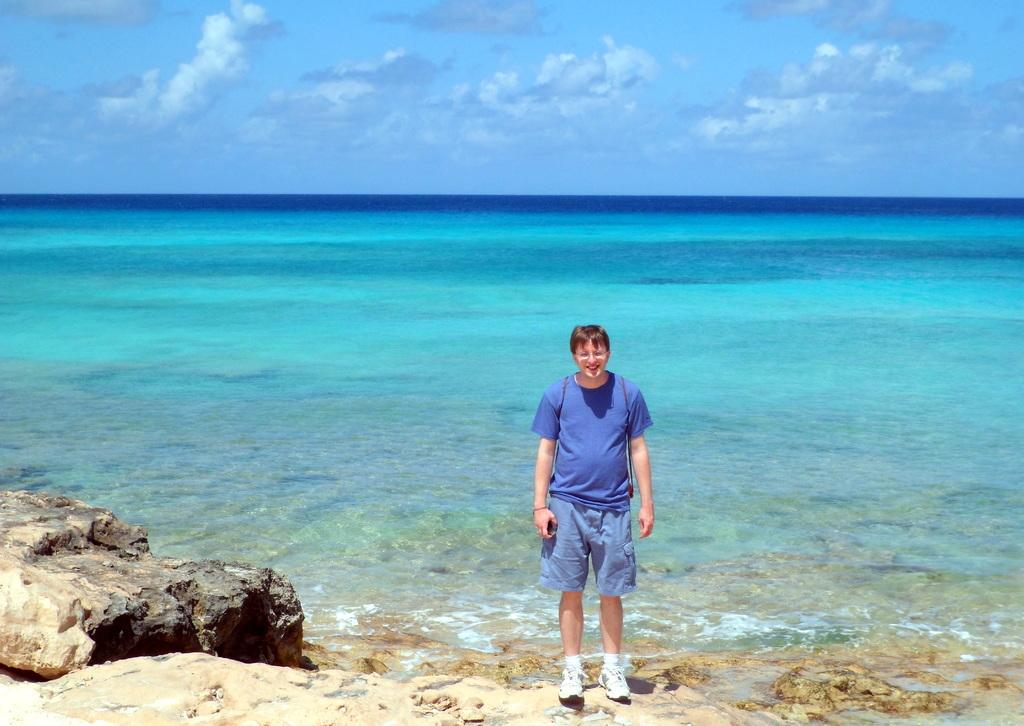What is the man in the image doing? The man is standing in the image and smiling. What can be seen in the background of the image? There is an ocean in the background of the image. What is the condition of the sky in the image? The sky is cloudy in the image. What object is located on the left side in the front of the image? There is a stone on the left side in the front of the image. How many cannons are present in the image? There are no cannons present in the image. Is there a fire visible in the image? There is no fire visible in the image. 